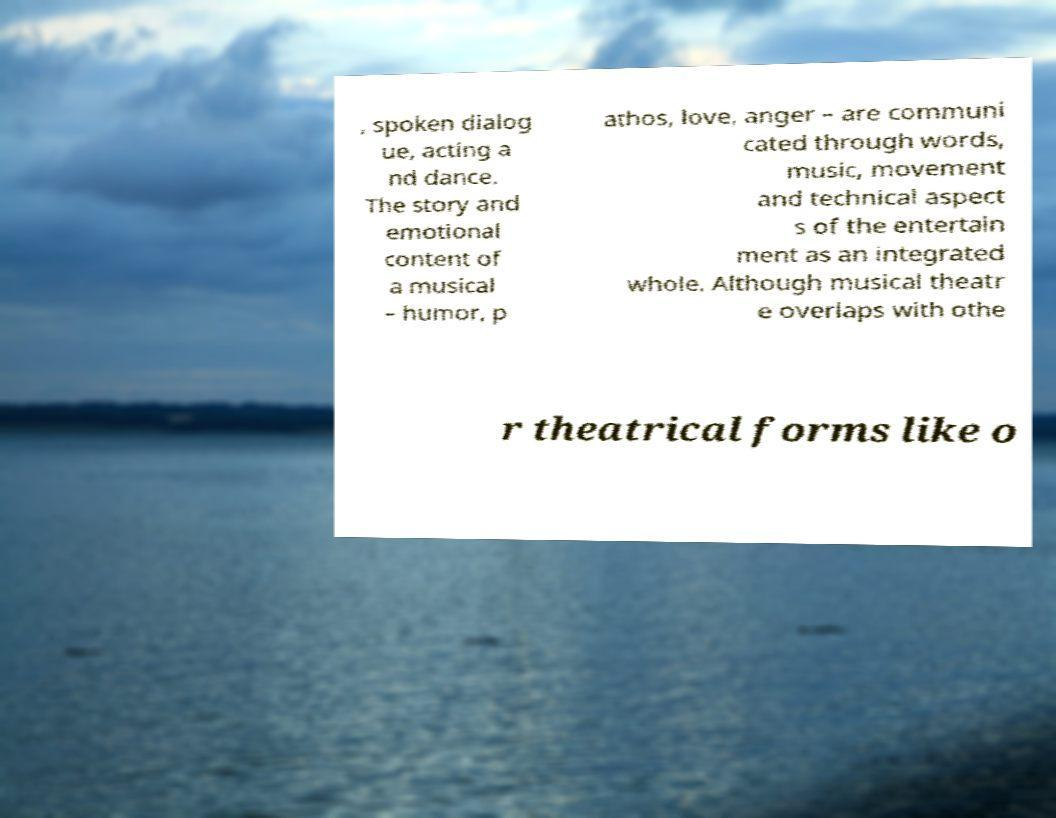There's text embedded in this image that I need extracted. Can you transcribe it verbatim? , spoken dialog ue, acting a nd dance. The story and emotional content of a musical – humor, p athos, love, anger – are communi cated through words, music, movement and technical aspect s of the entertain ment as an integrated whole. Although musical theatr e overlaps with othe r theatrical forms like o 